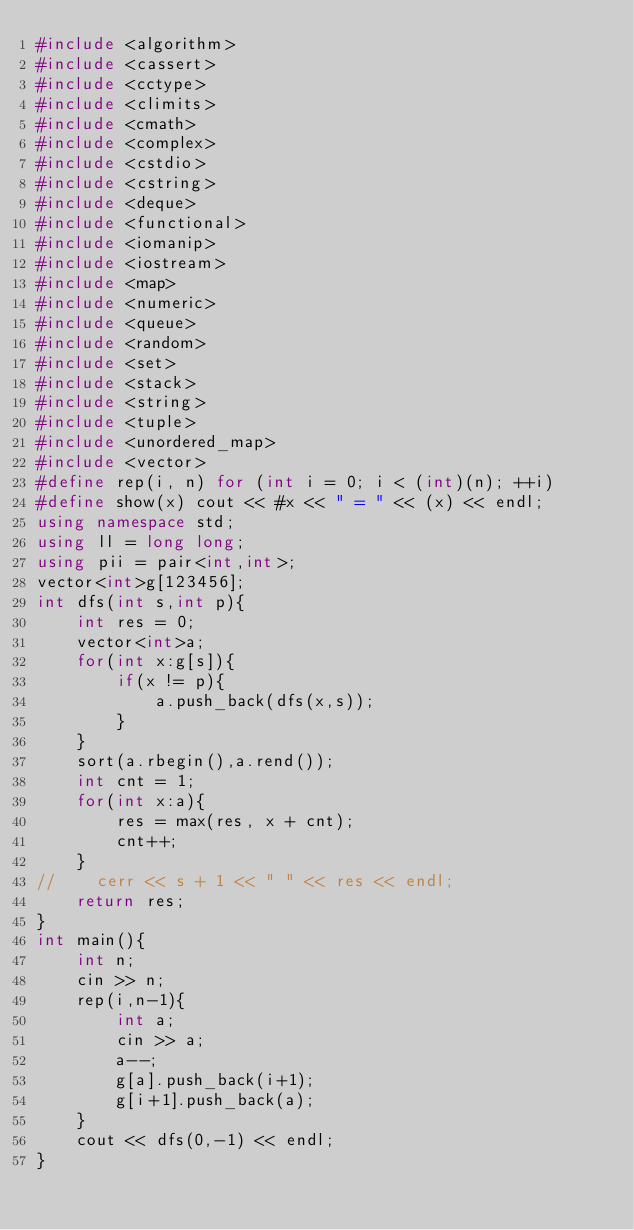<code> <loc_0><loc_0><loc_500><loc_500><_C++_>#include <algorithm>
#include <cassert>
#include <cctype>
#include <climits>
#include <cmath>
#include <complex>
#include <cstdio>
#include <cstring>
#include <deque>
#include <functional>
#include <iomanip>
#include <iostream>
#include <map>
#include <numeric>
#include <queue>
#include <random>
#include <set>
#include <stack>
#include <string>
#include <tuple>
#include <unordered_map>
#include <vector>
#define rep(i, n) for (int i = 0; i < (int)(n); ++i)
#define show(x) cout << #x << " = " << (x) << endl;
using namespace std;
using ll = long long;
using pii = pair<int,int>;
vector<int>g[123456];
int dfs(int s,int p){
    int res = 0;
    vector<int>a;
    for(int x:g[s]){
        if(x != p){
            a.push_back(dfs(x,s));
        }
    }
    sort(a.rbegin(),a.rend());
    int cnt = 1;
    for(int x:a){
        res = max(res, x + cnt);
        cnt++;
    }
//    cerr << s + 1 << " " << res << endl;
    return res;
}
int main(){
    int n;
    cin >> n;
    rep(i,n-1){
        int a;
        cin >> a;
        a--;
        g[a].push_back(i+1);
        g[i+1].push_back(a);
    }
    cout << dfs(0,-1) << endl;
}</code> 